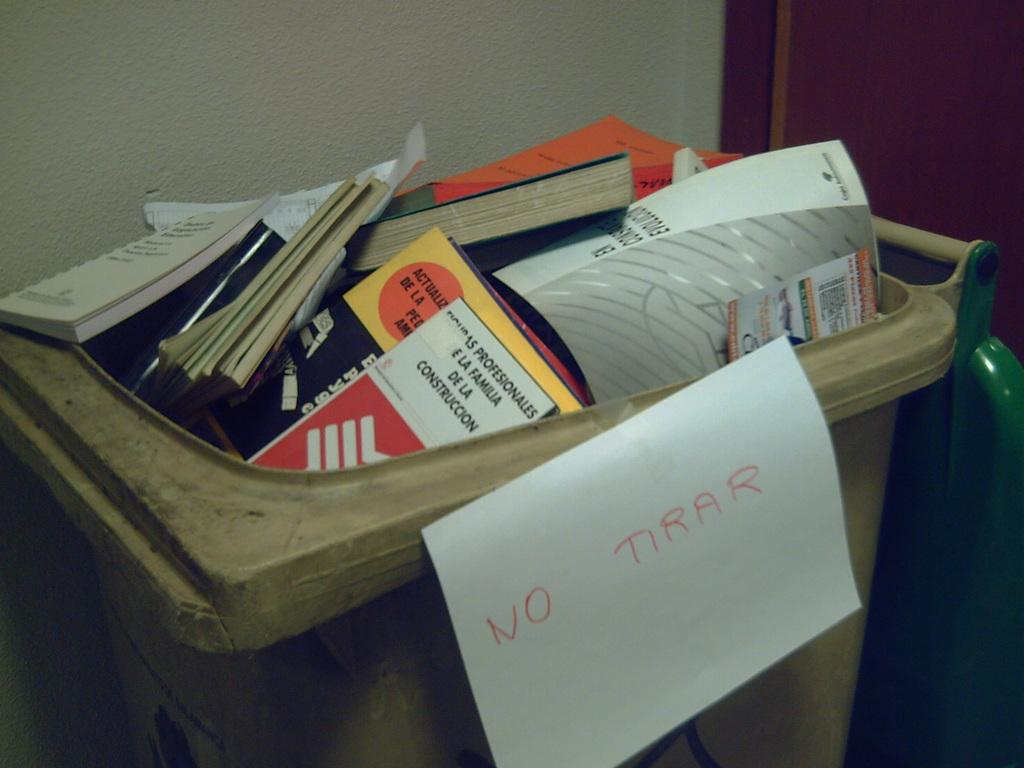<image>
Present a compact description of the photo's key features. A full gray trash can with text "NO TIRAR" on a white piece of paper attached to the trash can. 